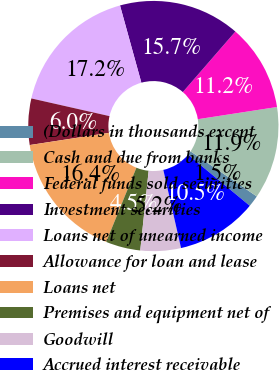Convert chart. <chart><loc_0><loc_0><loc_500><loc_500><pie_chart><fcel>(Dollars in thousands except<fcel>Cash and due from banks<fcel>Federal funds sold securities<fcel>Investment securities<fcel>Loans net of unearned income<fcel>Allowance for loan and lease<fcel>Loans net<fcel>Premises and equipment net of<fcel>Goodwill<fcel>Accrued interest receivable<nl><fcel>1.49%<fcel>11.94%<fcel>11.19%<fcel>15.67%<fcel>17.16%<fcel>5.97%<fcel>16.42%<fcel>4.48%<fcel>5.22%<fcel>10.45%<nl></chart> 